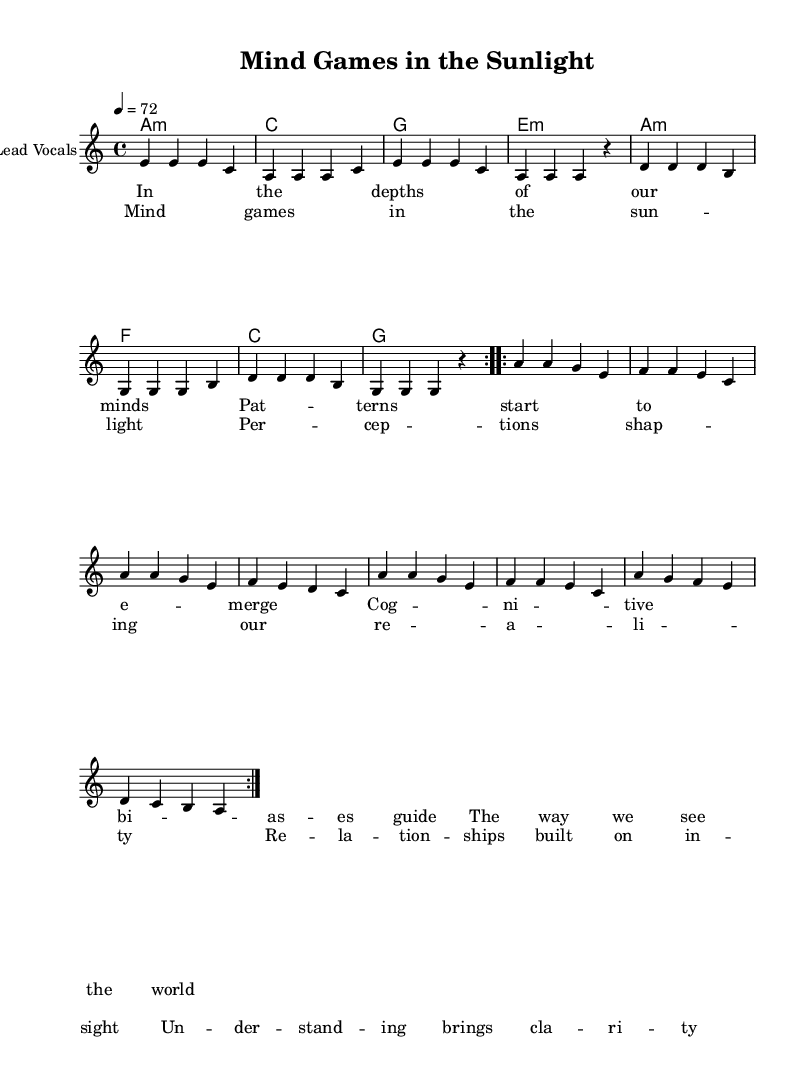What is the key signature of this music? The key signature is A minor, which has no sharps or flats represented in the sheet.
Answer: A minor What is the time signature of this music? The time signature is indicated as 4/4, meaning there are four beats in each measure and a quarter note receives one beat.
Answer: 4/4 What is the tempo marking for this music? The tempo marking is 4 = 72, indicating that the tempo is set to 72 beats per minute.
Answer: 72 How many measures are in the verse? The verse consists of 8 measures, as counted by looking at the notations and the repeat signs indicating the section length.
Answer: 8 What chord is played with the first measure of the chorus? The first measure of the chorus is played with an A minor chord as indicated in the chord progression above the staff.
Answer: A minor What theme is represented in the lyrics of this song? The lyrics explore perceptions and relationships, highlighting cognitive biases and understanding in human interactions, as suggested by the lines.
Answer: Perceptions and relationships How does the music style enhance the lyrical content? The reggae style enhances the lyrical content by providing a laid-back rhythm that supports the introspective and reflective themes of human behavior and relationships.
Answer: Laid-back rhythm 